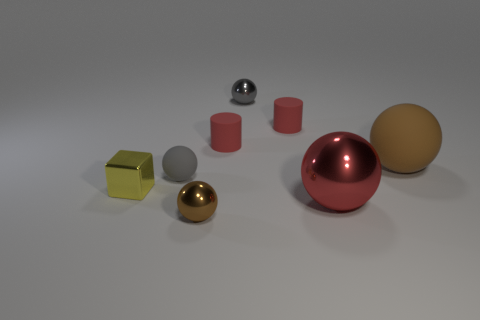What number of other things are there of the same color as the small rubber ball?
Ensure brevity in your answer.  1. What number of things are either large metal objects that are behind the tiny brown ball or tiny yellow cubes?
Make the answer very short. 2. Is the color of the block the same as the tiny metal ball behind the gray matte ball?
Your answer should be compact. No. Is there anything else that is the same size as the metallic cube?
Your response must be concise. Yes. There is a brown object right of the metallic ball in front of the red metal sphere; what size is it?
Provide a succinct answer. Large. What number of things are cyan matte blocks or brown shiny spheres in front of the big matte thing?
Ensure brevity in your answer.  1. There is a brown object in front of the tiny yellow cube; is it the same shape as the small gray matte thing?
Your response must be concise. Yes. How many small red cylinders are behind the large ball in front of the tiny yellow metal cube that is in front of the brown rubber ball?
Your answer should be very brief. 2. Is there anything else that has the same shape as the small yellow thing?
Provide a short and direct response. No. What number of objects are either large brown balls or large yellow matte cylinders?
Provide a short and direct response. 1. 